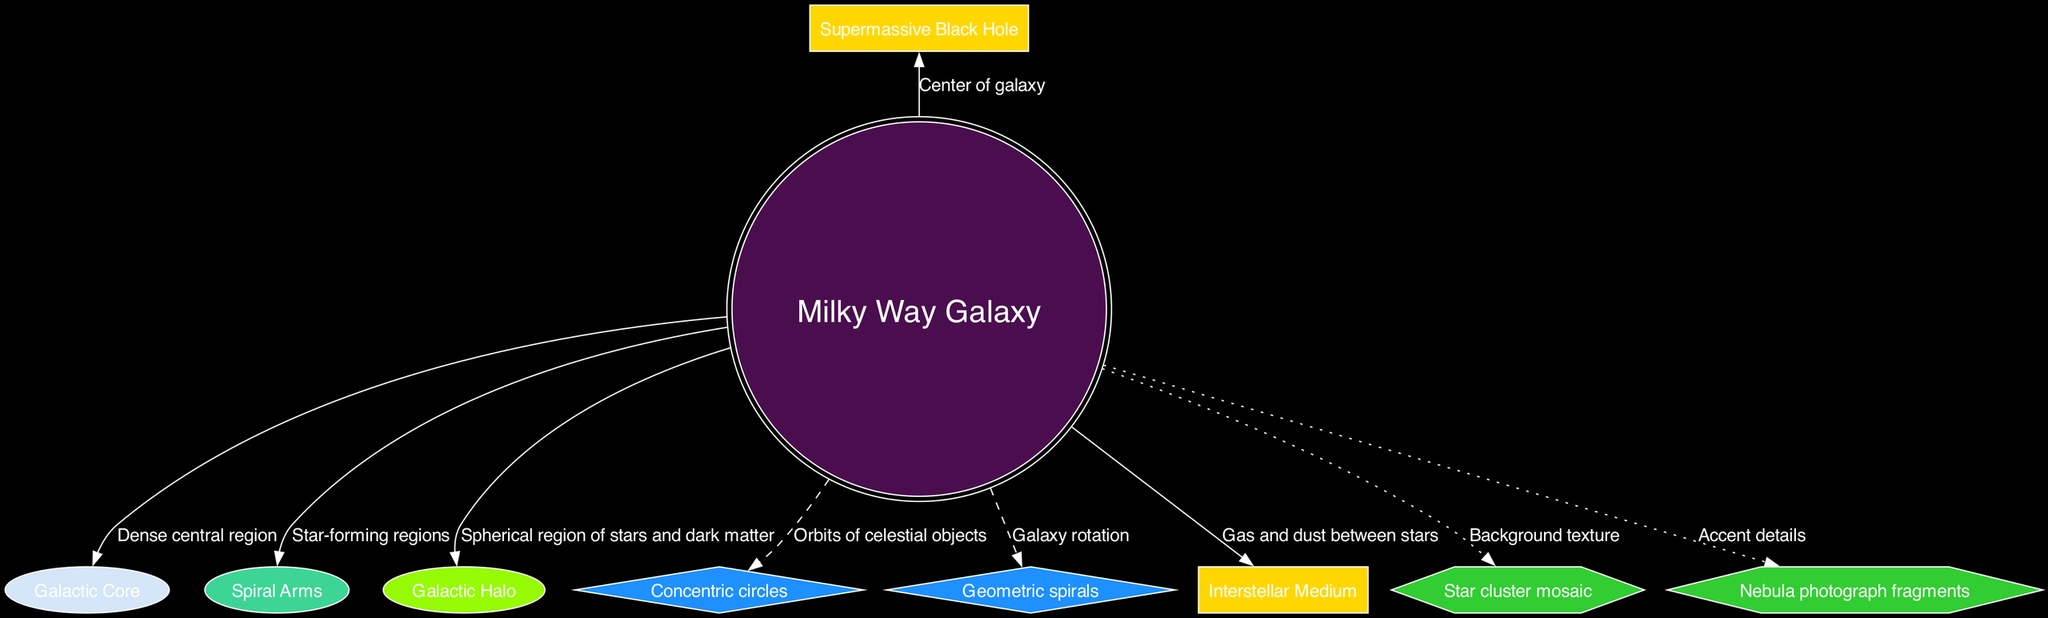What is the name of the central node? The central node is labeled "Milky Way Galaxy." This is the starting point of the diagram and represents the main focus of the galactic structure.
Answer: Milky Way Galaxy How many main structures are depicted? The diagram includes three main structures: Galactic Core, Spiral Arms, and Galactic Halo. By counting the labeled nodes associated with these structures, we confirm the total.
Answer: 3 What texture is associated with the Galactic Core? The Galactic Core is described as having a "Vibrant cosmic nebula" texture. This can be found in the main structures section of the data.
Answer: Vibrant cosmic nebula What shape represents the orbits of celestial objects? The concentric circles represent the orbits of celestial objects, as stated in the abstract elements section of the data.
Answer: Concentric circles Where is the Supermassive Black Hole located? The Supermassive Black Hole is located at the "Center of galaxy" as indicated in the scientific annotations section.
Answer: Center of galaxy Which main structure is associated with star-forming regions? The Spiral Arms are noted as the regions where star formation occurs, drawn in the context of the main structures in the diagram.
Answer: Spiral Arms What color are the nodes for scientific annotations? The nodes for scientific annotations are represented with a box shape and filled with gold color, consistent with the details in the diagram's node attributes.
Answer: Gold What is the application of the "Nebula photograph fragments"? The "Nebula photograph fragments" are applied as "Accent details" within the context of collage textures. This is specified in the collage textures section of the data.
Answer: Accent details What representation is indicated by geometric spirals? The geometric spirals represent "Galaxy rotation," which is defined in the abstract elements section of the data.
Answer: Galaxy rotation What is the visual relationship between the Galactic Halo and the Milky Way Galaxy? The Galactic Halo is depicted as a spherical region surrounding the Milky Way Galaxy, showing a visual connection through an edge linking the two nodes.
Answer: Spherical region 